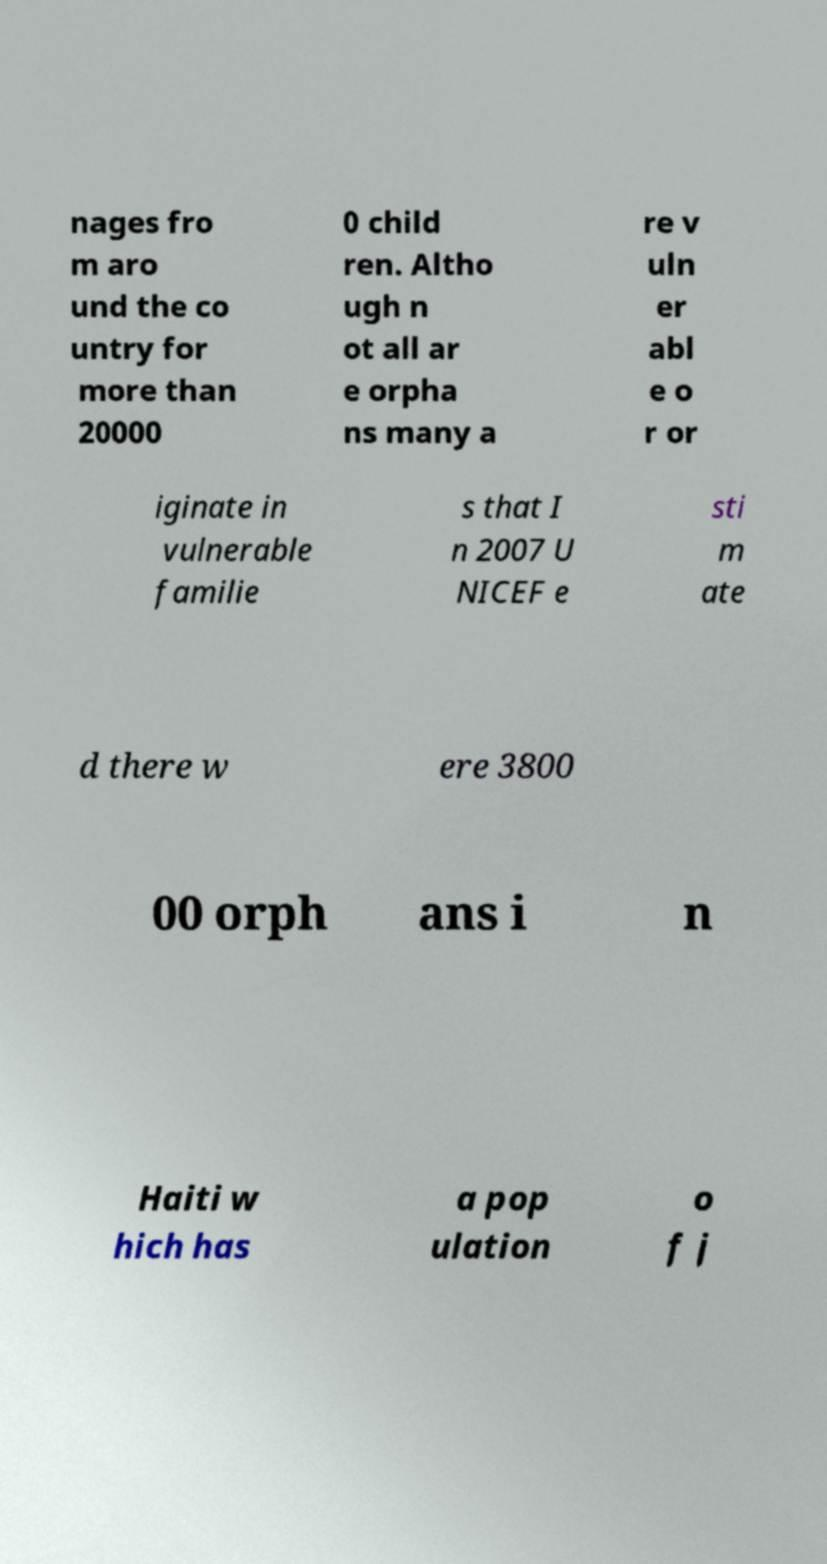Can you read and provide the text displayed in the image?This photo seems to have some interesting text. Can you extract and type it out for me? nages fro m aro und the co untry for more than 20000 0 child ren. Altho ugh n ot all ar e orpha ns many a re v uln er abl e o r or iginate in vulnerable familie s that I n 2007 U NICEF e sti m ate d there w ere 3800 00 orph ans i n Haiti w hich has a pop ulation o f j 